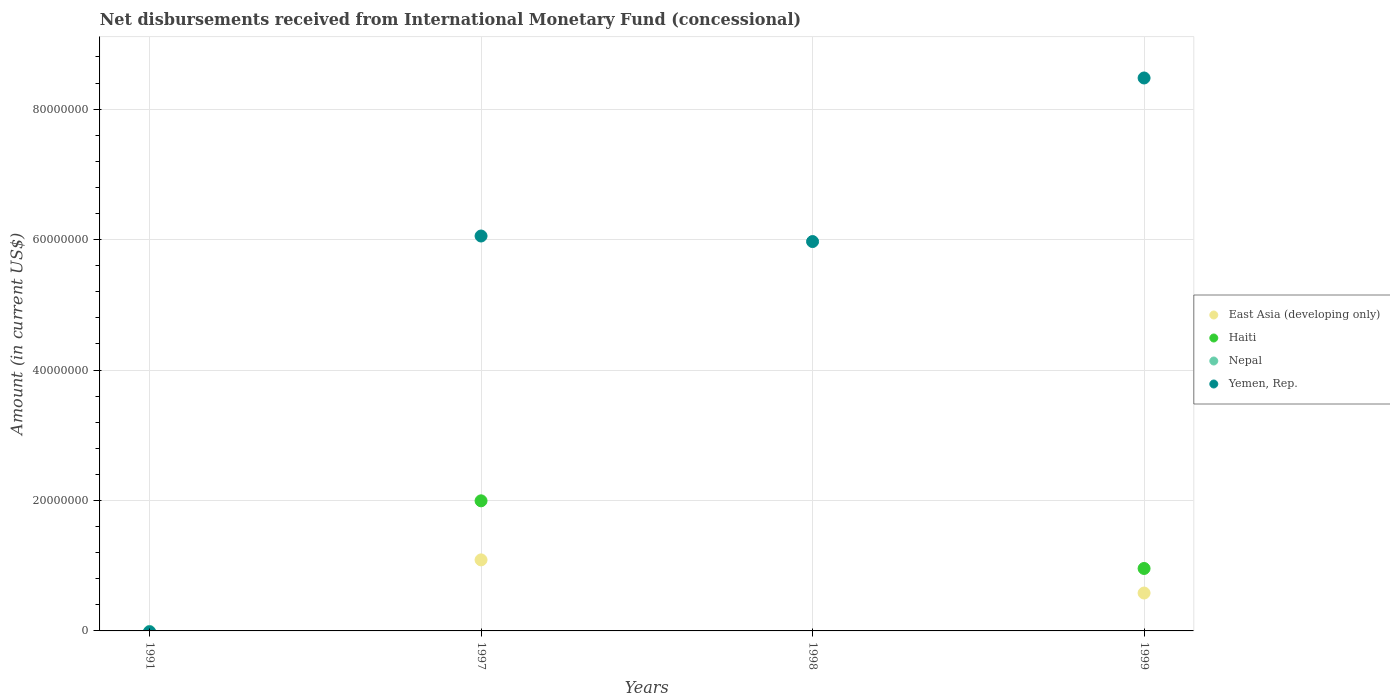How many different coloured dotlines are there?
Make the answer very short. 3. Is the number of dotlines equal to the number of legend labels?
Keep it short and to the point. No. What is the amount of disbursements received from International Monetary Fund in Yemen, Rep. in 1998?
Make the answer very short. 5.97e+07. Across all years, what is the maximum amount of disbursements received from International Monetary Fund in Yemen, Rep.?
Offer a terse response. 8.48e+07. In which year was the amount of disbursements received from International Monetary Fund in Haiti maximum?
Offer a very short reply. 1997. What is the difference between the amount of disbursements received from International Monetary Fund in Yemen, Rep. in 1998 and that in 1999?
Provide a short and direct response. -2.51e+07. What is the average amount of disbursements received from International Monetary Fund in Haiti per year?
Your response must be concise. 7.38e+06. In the year 1999, what is the difference between the amount of disbursements received from International Monetary Fund in Yemen, Rep. and amount of disbursements received from International Monetary Fund in Haiti?
Provide a short and direct response. 7.52e+07. In how many years, is the amount of disbursements received from International Monetary Fund in Nepal greater than 32000000 US$?
Provide a short and direct response. 0. What is the ratio of the amount of disbursements received from International Monetary Fund in East Asia (developing only) in 1997 to that in 1999?
Make the answer very short. 1.87. What is the difference between the highest and the lowest amount of disbursements received from International Monetary Fund in East Asia (developing only)?
Provide a short and direct response. 1.09e+07. Is it the case that in every year, the sum of the amount of disbursements received from International Monetary Fund in East Asia (developing only) and amount of disbursements received from International Monetary Fund in Haiti  is greater than the sum of amount of disbursements received from International Monetary Fund in Nepal and amount of disbursements received from International Monetary Fund in Yemen, Rep.?
Offer a terse response. No. Is the amount of disbursements received from International Monetary Fund in East Asia (developing only) strictly greater than the amount of disbursements received from International Monetary Fund in Haiti over the years?
Offer a very short reply. No. Is the amount of disbursements received from International Monetary Fund in Nepal strictly less than the amount of disbursements received from International Monetary Fund in Yemen, Rep. over the years?
Your answer should be compact. No. How many dotlines are there?
Give a very brief answer. 3. How many years are there in the graph?
Keep it short and to the point. 4. Does the graph contain grids?
Offer a very short reply. Yes. How many legend labels are there?
Your answer should be compact. 4. How are the legend labels stacked?
Your answer should be very brief. Vertical. What is the title of the graph?
Give a very brief answer. Net disbursements received from International Monetary Fund (concessional). Does "Qatar" appear as one of the legend labels in the graph?
Your answer should be compact. No. What is the label or title of the Y-axis?
Keep it short and to the point. Amount (in current US$). What is the Amount (in current US$) in East Asia (developing only) in 1991?
Provide a short and direct response. 0. What is the Amount (in current US$) of East Asia (developing only) in 1997?
Your answer should be very brief. 1.09e+07. What is the Amount (in current US$) in Haiti in 1997?
Ensure brevity in your answer.  1.99e+07. What is the Amount (in current US$) of Yemen, Rep. in 1997?
Provide a short and direct response. 6.05e+07. What is the Amount (in current US$) of East Asia (developing only) in 1998?
Keep it short and to the point. 0. What is the Amount (in current US$) of Yemen, Rep. in 1998?
Offer a very short reply. 5.97e+07. What is the Amount (in current US$) of East Asia (developing only) in 1999?
Provide a succinct answer. 5.81e+06. What is the Amount (in current US$) of Haiti in 1999?
Ensure brevity in your answer.  9.57e+06. What is the Amount (in current US$) in Nepal in 1999?
Keep it short and to the point. 0. What is the Amount (in current US$) in Yemen, Rep. in 1999?
Offer a very short reply. 8.48e+07. Across all years, what is the maximum Amount (in current US$) of East Asia (developing only)?
Offer a very short reply. 1.09e+07. Across all years, what is the maximum Amount (in current US$) of Haiti?
Ensure brevity in your answer.  1.99e+07. Across all years, what is the maximum Amount (in current US$) in Yemen, Rep.?
Offer a terse response. 8.48e+07. Across all years, what is the minimum Amount (in current US$) in East Asia (developing only)?
Your answer should be very brief. 0. Across all years, what is the minimum Amount (in current US$) of Haiti?
Offer a very short reply. 0. What is the total Amount (in current US$) of East Asia (developing only) in the graph?
Your response must be concise. 1.67e+07. What is the total Amount (in current US$) of Haiti in the graph?
Make the answer very short. 2.95e+07. What is the total Amount (in current US$) of Yemen, Rep. in the graph?
Provide a short and direct response. 2.05e+08. What is the difference between the Amount (in current US$) in Yemen, Rep. in 1997 and that in 1998?
Keep it short and to the point. 8.50e+05. What is the difference between the Amount (in current US$) in East Asia (developing only) in 1997 and that in 1999?
Keep it short and to the point. 5.08e+06. What is the difference between the Amount (in current US$) in Haiti in 1997 and that in 1999?
Offer a very short reply. 1.04e+07. What is the difference between the Amount (in current US$) of Yemen, Rep. in 1997 and that in 1999?
Your answer should be compact. -2.42e+07. What is the difference between the Amount (in current US$) in Yemen, Rep. in 1998 and that in 1999?
Your response must be concise. -2.51e+07. What is the difference between the Amount (in current US$) in East Asia (developing only) in 1997 and the Amount (in current US$) in Yemen, Rep. in 1998?
Your response must be concise. -4.88e+07. What is the difference between the Amount (in current US$) of Haiti in 1997 and the Amount (in current US$) of Yemen, Rep. in 1998?
Offer a terse response. -3.98e+07. What is the difference between the Amount (in current US$) in East Asia (developing only) in 1997 and the Amount (in current US$) in Haiti in 1999?
Your response must be concise. 1.32e+06. What is the difference between the Amount (in current US$) of East Asia (developing only) in 1997 and the Amount (in current US$) of Yemen, Rep. in 1999?
Offer a very short reply. -7.39e+07. What is the difference between the Amount (in current US$) in Haiti in 1997 and the Amount (in current US$) in Yemen, Rep. in 1999?
Your response must be concise. -6.48e+07. What is the average Amount (in current US$) in East Asia (developing only) per year?
Your answer should be compact. 4.18e+06. What is the average Amount (in current US$) of Haiti per year?
Make the answer very short. 7.38e+06. What is the average Amount (in current US$) in Yemen, Rep. per year?
Ensure brevity in your answer.  5.13e+07. In the year 1997, what is the difference between the Amount (in current US$) in East Asia (developing only) and Amount (in current US$) in Haiti?
Your answer should be very brief. -9.06e+06. In the year 1997, what is the difference between the Amount (in current US$) of East Asia (developing only) and Amount (in current US$) of Yemen, Rep.?
Ensure brevity in your answer.  -4.97e+07. In the year 1997, what is the difference between the Amount (in current US$) of Haiti and Amount (in current US$) of Yemen, Rep.?
Provide a short and direct response. -4.06e+07. In the year 1999, what is the difference between the Amount (in current US$) of East Asia (developing only) and Amount (in current US$) of Haiti?
Offer a terse response. -3.76e+06. In the year 1999, what is the difference between the Amount (in current US$) in East Asia (developing only) and Amount (in current US$) in Yemen, Rep.?
Offer a very short reply. -7.90e+07. In the year 1999, what is the difference between the Amount (in current US$) in Haiti and Amount (in current US$) in Yemen, Rep.?
Keep it short and to the point. -7.52e+07. What is the ratio of the Amount (in current US$) in Yemen, Rep. in 1997 to that in 1998?
Make the answer very short. 1.01. What is the ratio of the Amount (in current US$) in East Asia (developing only) in 1997 to that in 1999?
Offer a terse response. 1.87. What is the ratio of the Amount (in current US$) of Haiti in 1997 to that in 1999?
Offer a terse response. 2.08. What is the ratio of the Amount (in current US$) in Yemen, Rep. in 1997 to that in 1999?
Your answer should be compact. 0.71. What is the ratio of the Amount (in current US$) in Yemen, Rep. in 1998 to that in 1999?
Offer a terse response. 0.7. What is the difference between the highest and the second highest Amount (in current US$) of Yemen, Rep.?
Provide a short and direct response. 2.42e+07. What is the difference between the highest and the lowest Amount (in current US$) in East Asia (developing only)?
Keep it short and to the point. 1.09e+07. What is the difference between the highest and the lowest Amount (in current US$) in Haiti?
Keep it short and to the point. 1.99e+07. What is the difference between the highest and the lowest Amount (in current US$) of Yemen, Rep.?
Your answer should be very brief. 8.48e+07. 